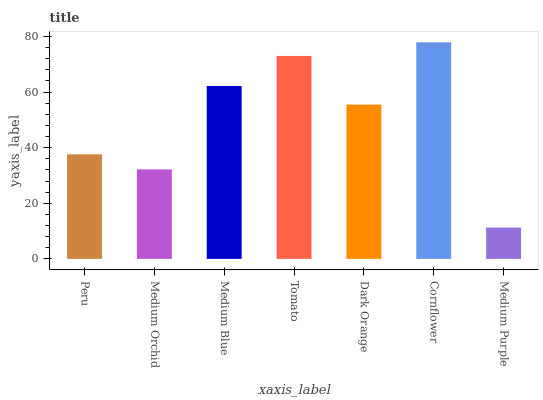Is Medium Orchid the minimum?
Answer yes or no. No. Is Medium Orchid the maximum?
Answer yes or no. No. Is Peru greater than Medium Orchid?
Answer yes or no. Yes. Is Medium Orchid less than Peru?
Answer yes or no. Yes. Is Medium Orchid greater than Peru?
Answer yes or no. No. Is Peru less than Medium Orchid?
Answer yes or no. No. Is Dark Orange the high median?
Answer yes or no. Yes. Is Dark Orange the low median?
Answer yes or no. Yes. Is Tomato the high median?
Answer yes or no. No. Is Cornflower the low median?
Answer yes or no. No. 